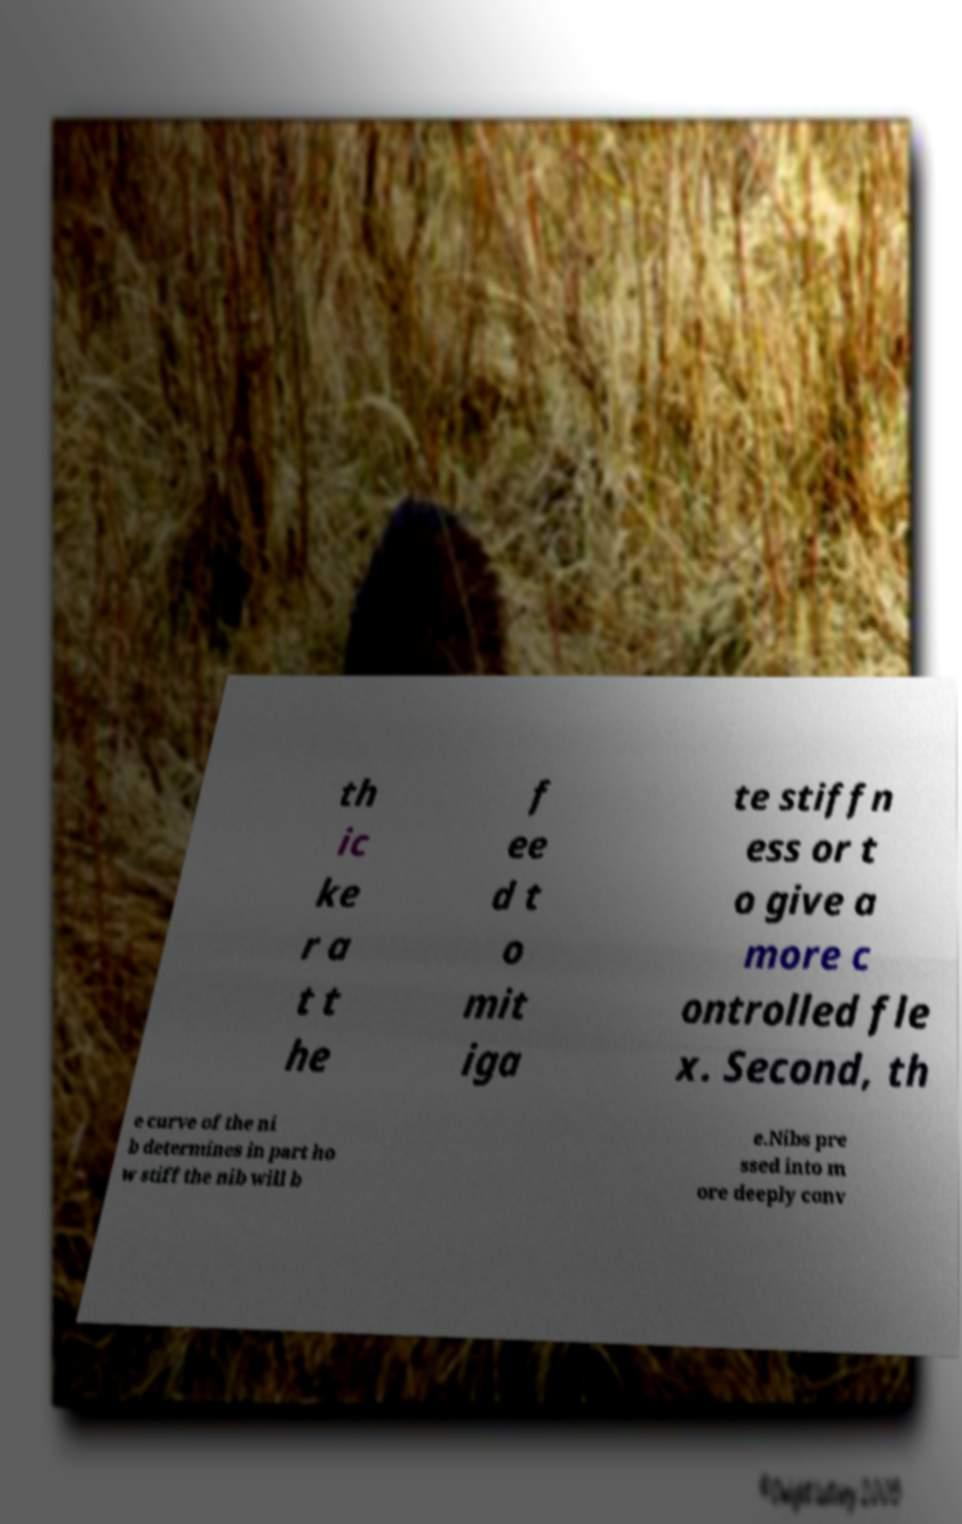Please identify and transcribe the text found in this image. th ic ke r a t t he f ee d t o mit iga te stiffn ess or t o give a more c ontrolled fle x. Second, th e curve of the ni b determines in part ho w stiff the nib will b e.Nibs pre ssed into m ore deeply conv 